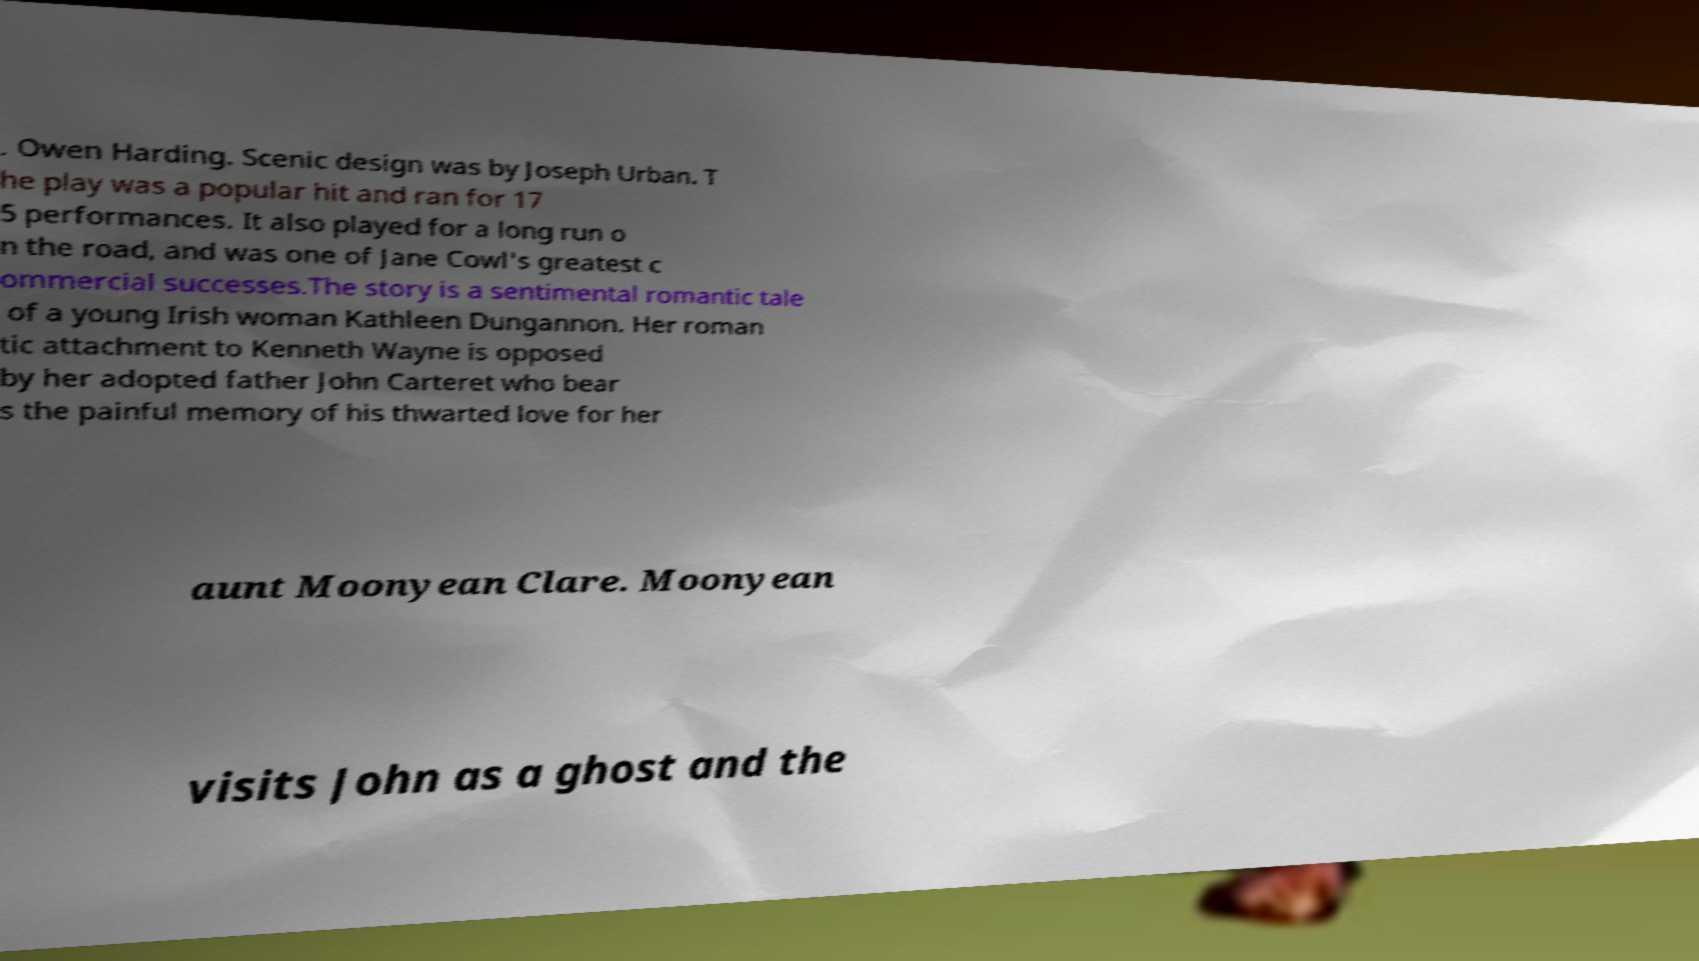There's text embedded in this image that I need extracted. Can you transcribe it verbatim? . Owen Harding. Scenic design was by Joseph Urban. T he play was a popular hit and ran for 17 5 performances. It also played for a long run o n the road, and was one of Jane Cowl's greatest c ommercial successes.The story is a sentimental romantic tale of a young Irish woman Kathleen Dungannon. Her roman tic attachment to Kenneth Wayne is opposed by her adopted father John Carteret who bear s the painful memory of his thwarted love for her aunt Moonyean Clare. Moonyean visits John as a ghost and the 